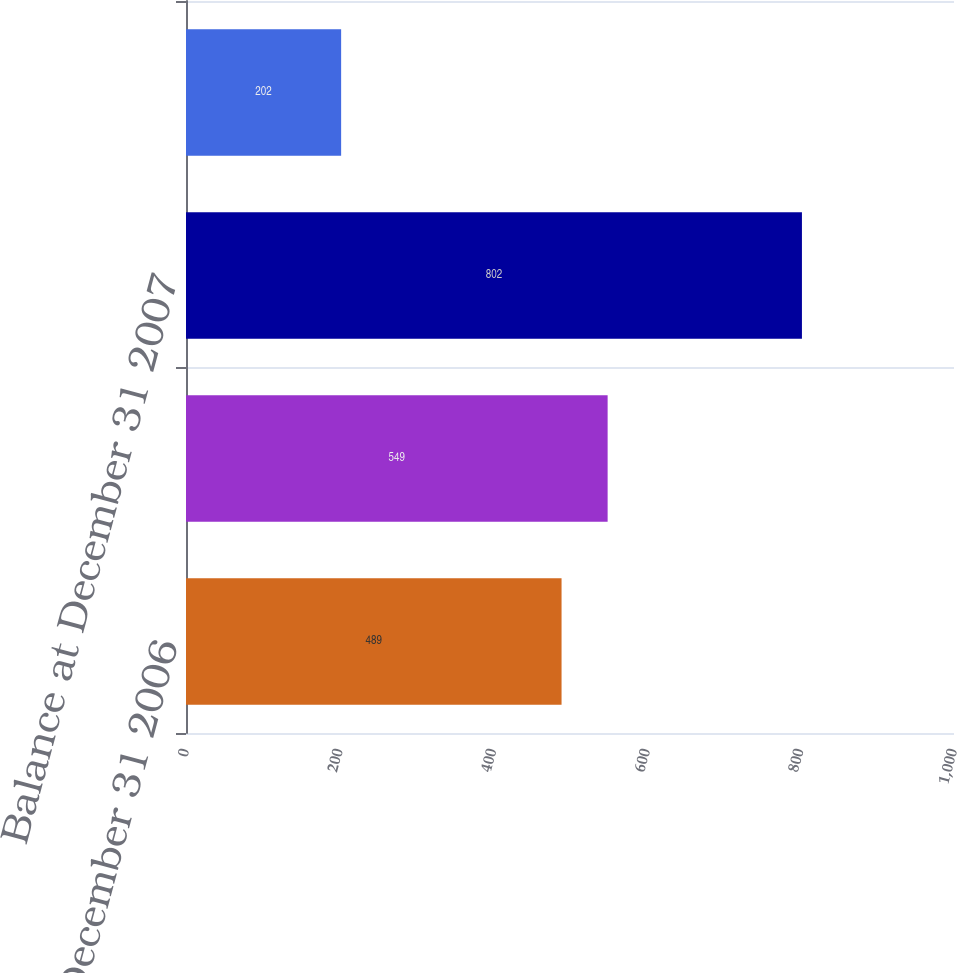<chart> <loc_0><loc_0><loc_500><loc_500><bar_chart><fcel>Balance at December 31 2006<fcel>Balance at January 1 2007<fcel>Balance at December 31 2007<fcel>Balance at December 31 2008<nl><fcel>489<fcel>549<fcel>802<fcel>202<nl></chart> 